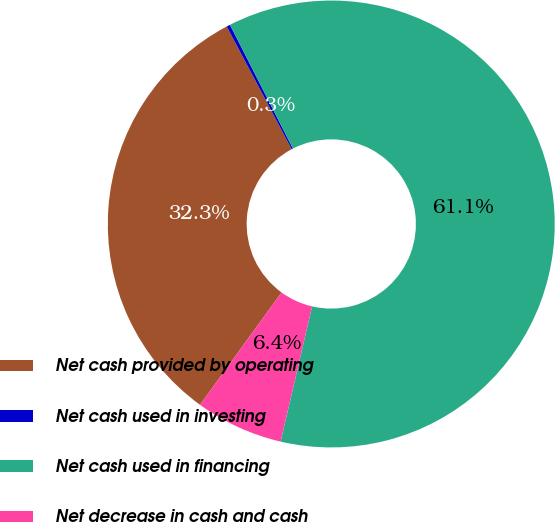Convert chart. <chart><loc_0><loc_0><loc_500><loc_500><pie_chart><fcel>Net cash provided by operating<fcel>Net cash used in investing<fcel>Net cash used in financing<fcel>Net decrease in cash and cash<nl><fcel>32.26%<fcel>0.26%<fcel>61.13%<fcel>6.35%<nl></chart> 